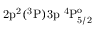Convert formula to latex. <formula><loc_0><loc_0><loc_500><loc_500>2 p ^ { 2 } ( ^ { 3 } P ) 3 p ^ { 4 } P _ { 5 / 2 } ^ { o }</formula> 